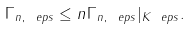<formula> <loc_0><loc_0><loc_500><loc_500>\Gamma _ { n , \ e p s } \leq n \Gamma _ { n , \ e p s } | _ { K _ { \ } e p s } .</formula> 